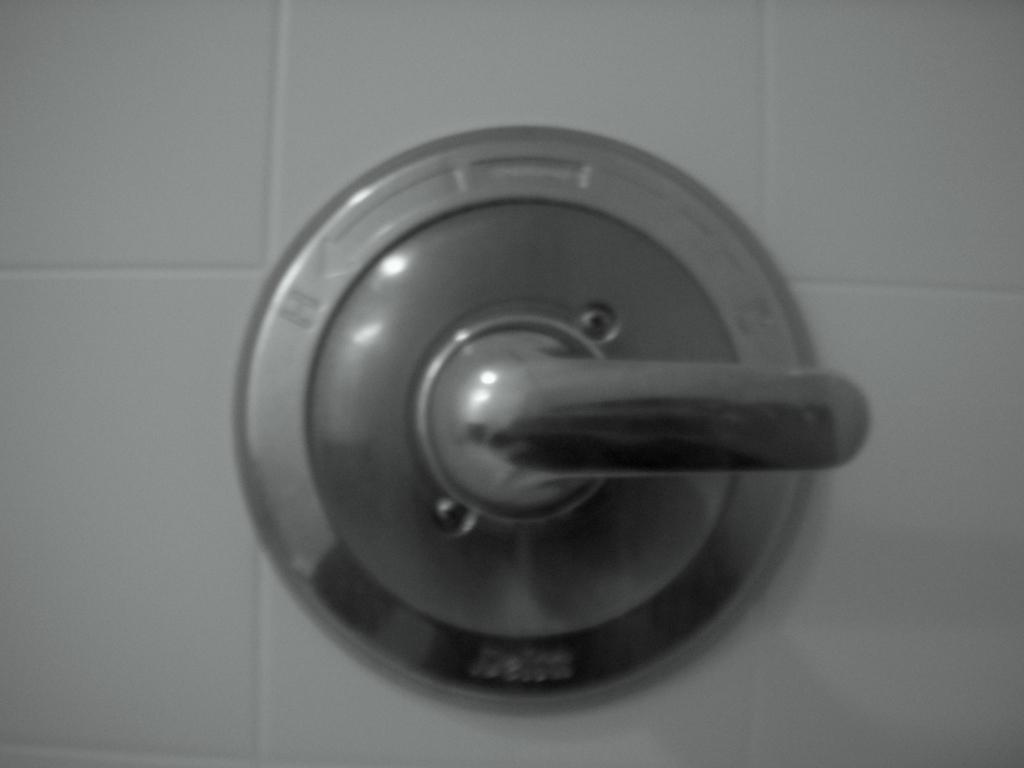Describe this image in one or two sentences. In this image there is a metal object which is fixed on the wall. 